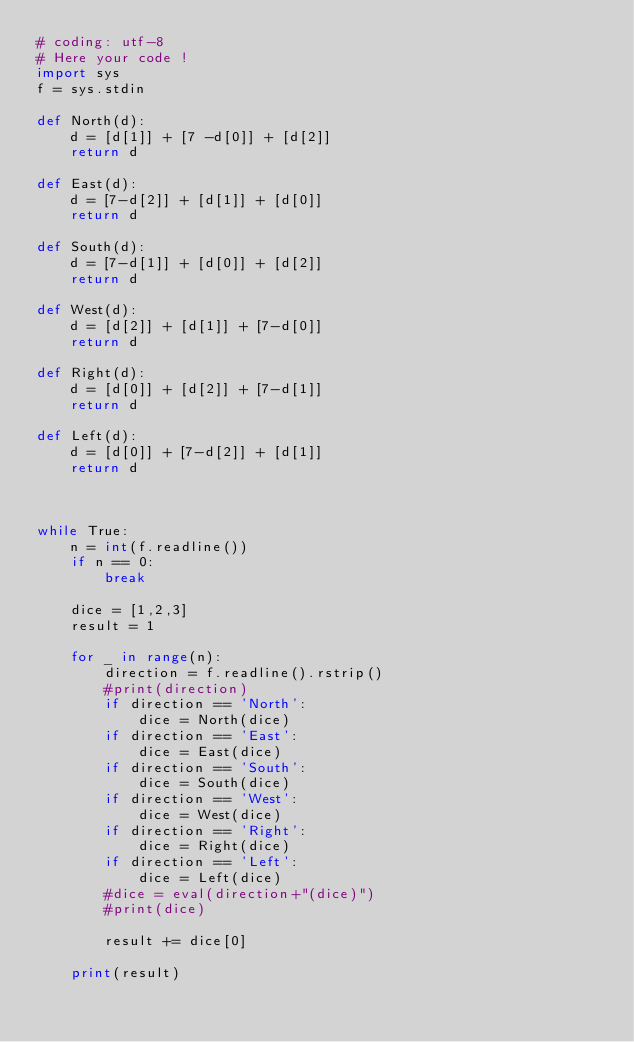<code> <loc_0><loc_0><loc_500><loc_500><_Python_># coding: utf-8
# Here your code !
import sys
f = sys.stdin

def North(d):
    d = [d[1]] + [7 -d[0]] + [d[2]]
    return d
      
def East(d):
    d = [7-d[2]] + [d[1]] + [d[0]]
    return d
      
def South(d):
    d = [7-d[1]] + [d[0]] + [d[2]]
    return d
  
def West(d):
    d = [d[2]] + [d[1]] + [7-d[0]]
    return d
  
def Right(d):
    d = [d[0]] + [d[2]] + [7-d[1]]
    return d
  
def Left(d):
    d = [d[0]] + [7-d[2]] + [d[1]]
    return d
  
  
  
while True:
    n = int(f.readline())
    if n == 0:
        break
      
    dice = [1,2,3]
    result = 1
      
    for _ in range(n):
        direction = f.readline().rstrip()
        #print(direction)
        if direction == 'North':
            dice = North(dice)
        if direction == 'East':
            dice = East(dice)
        if direction == 'South':
            dice = South(dice)
        if direction == 'West':
            dice = West(dice)
        if direction == 'Right':
            dice = Right(dice)
        if direction == 'Left':
            dice = Left(dice)
        #dice = eval(direction+"(dice)")
        #print(dice)
          
        result += dice[0]
      
    print(result)</code> 